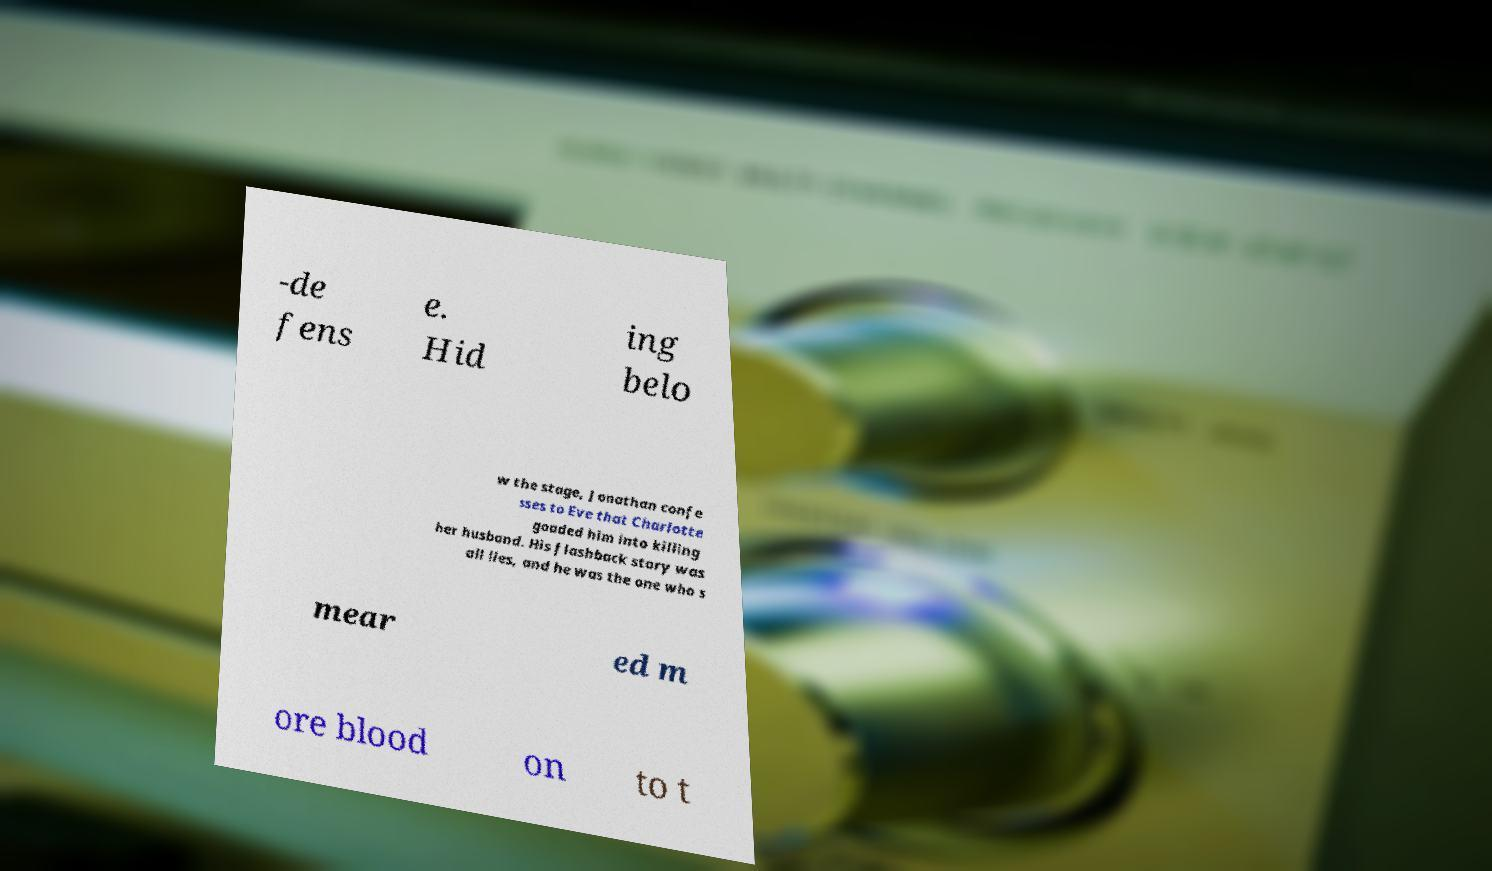Can you read and provide the text displayed in the image?This photo seems to have some interesting text. Can you extract and type it out for me? -de fens e. Hid ing belo w the stage, Jonathan confe sses to Eve that Charlotte goaded him into killing her husband. His flashback story was all lies, and he was the one who s mear ed m ore blood on to t 